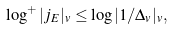<formula> <loc_0><loc_0><loc_500><loc_500>\log ^ { + } | j _ { E } | _ { v } \leq \log | 1 / \Delta _ { v } | _ { v } ,</formula> 